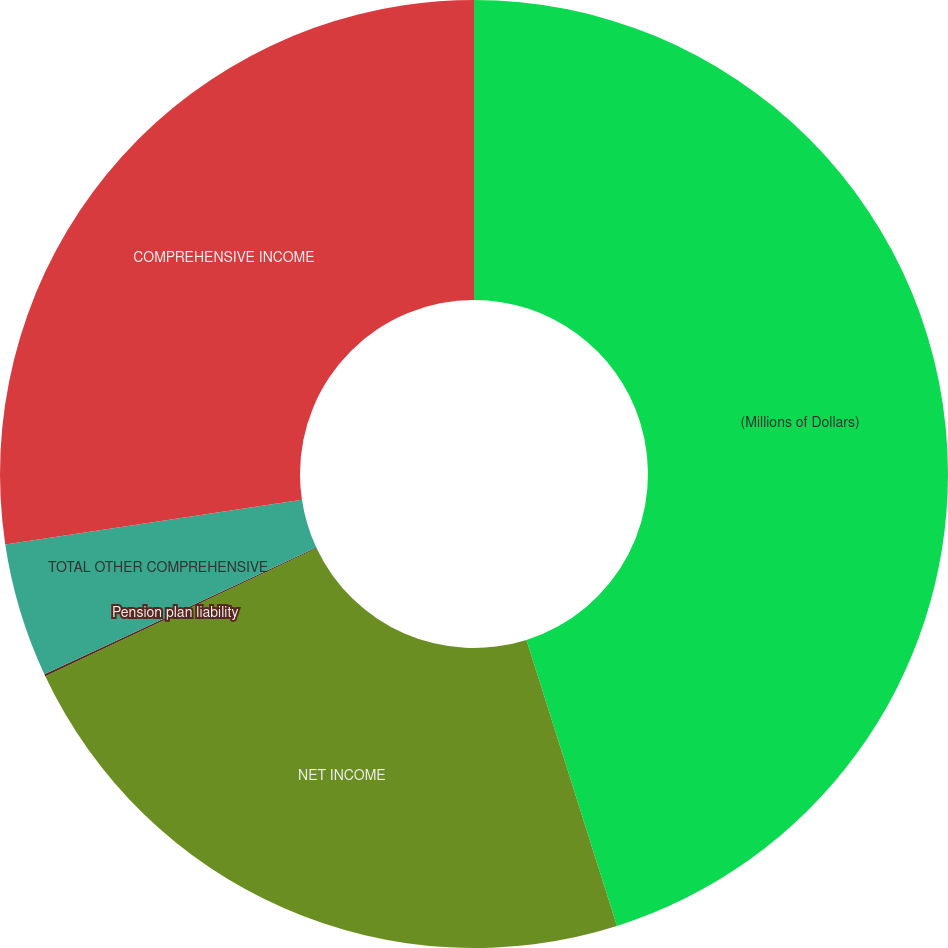Convert chart to OTSL. <chart><loc_0><loc_0><loc_500><loc_500><pie_chart><fcel>(Millions of Dollars)<fcel>NET INCOME<fcel>Pension plan liability<fcel>TOTAL OTHER COMPREHENSIVE<fcel>COMPREHENSIVE INCOME<nl><fcel>45.12%<fcel>22.86%<fcel>0.07%<fcel>4.57%<fcel>27.37%<nl></chart> 